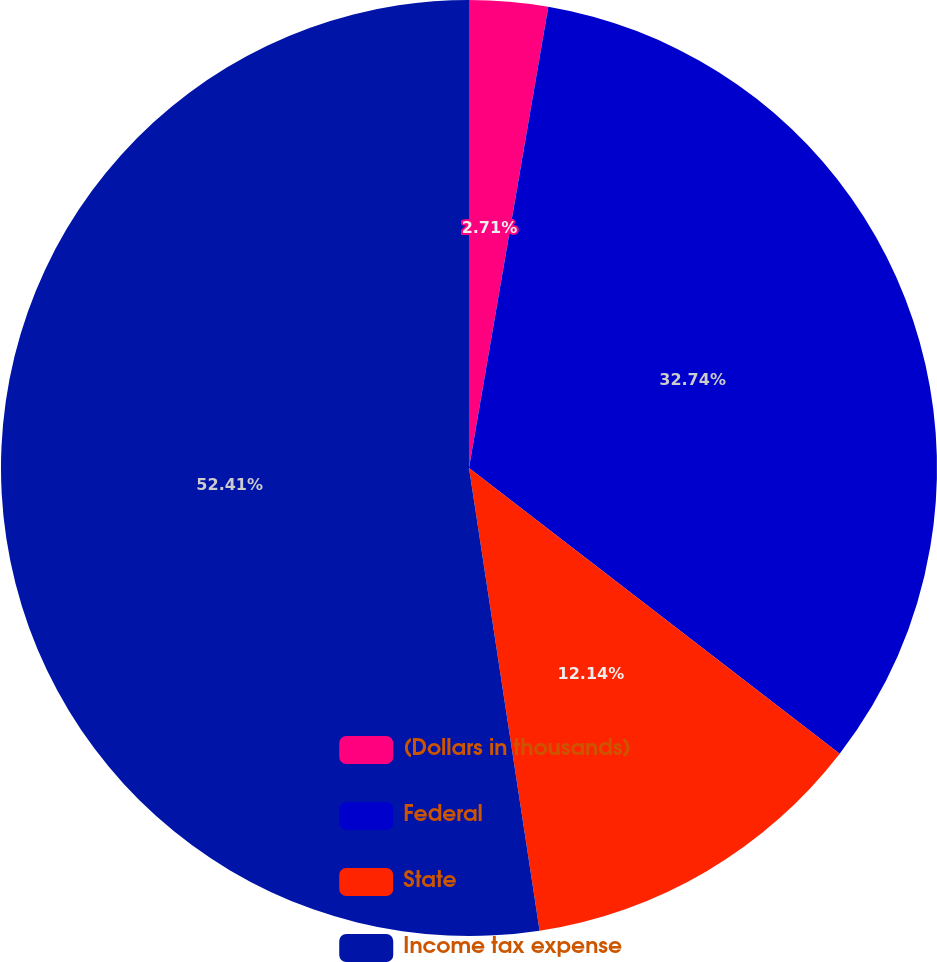Convert chart. <chart><loc_0><loc_0><loc_500><loc_500><pie_chart><fcel>(Dollars in thousands)<fcel>Federal<fcel>State<fcel>Income tax expense<nl><fcel>2.71%<fcel>32.74%<fcel>12.14%<fcel>52.41%<nl></chart> 